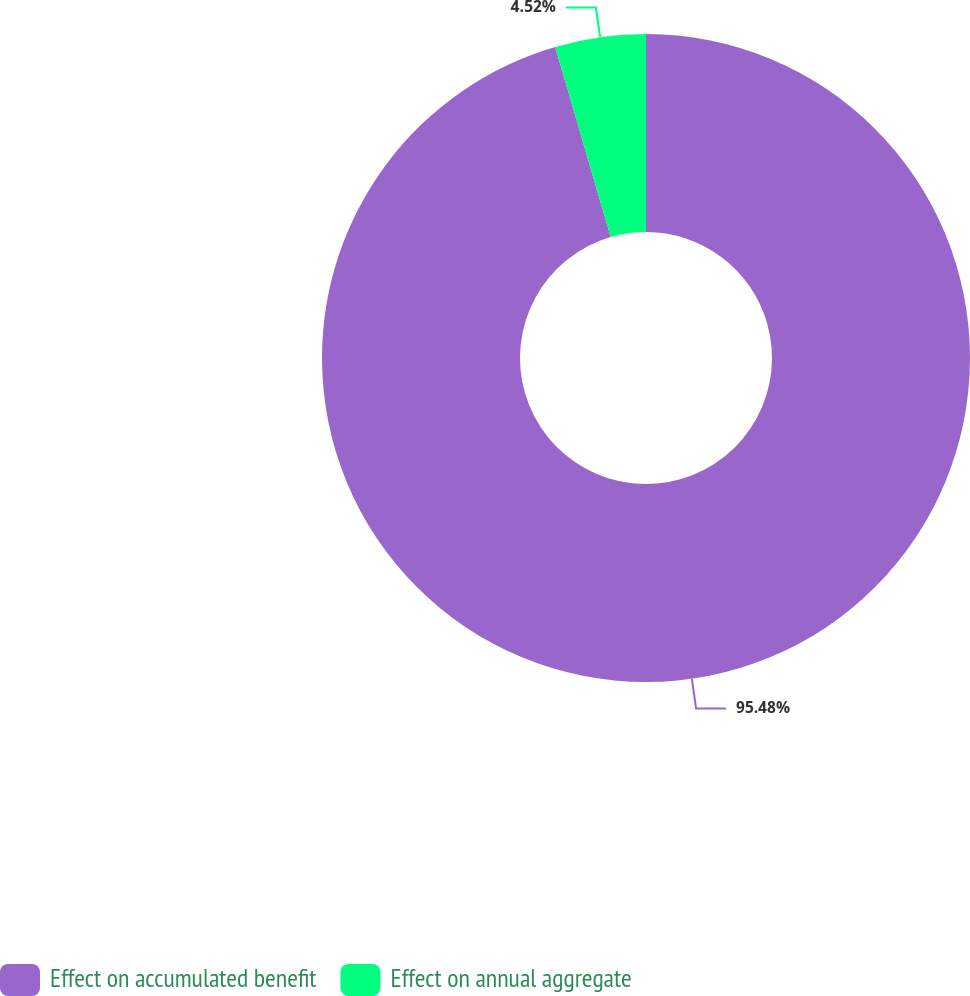Convert chart. <chart><loc_0><loc_0><loc_500><loc_500><pie_chart><fcel>Effect on accumulated benefit<fcel>Effect on annual aggregate<nl><fcel>95.48%<fcel>4.52%<nl></chart> 